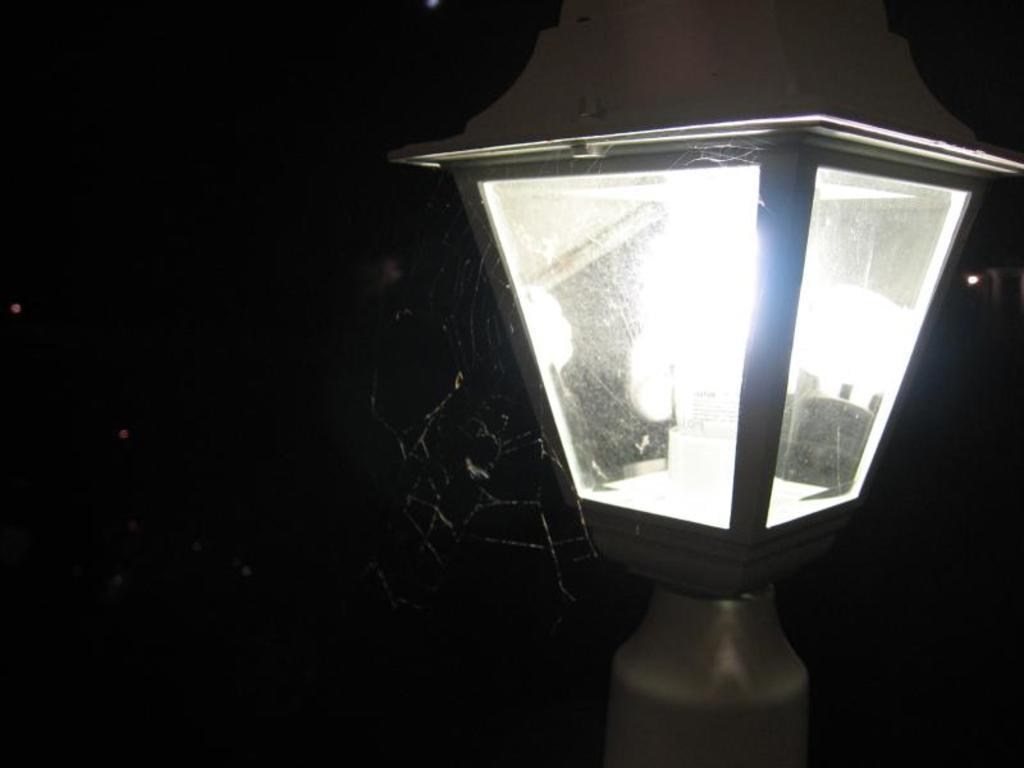Can you describe this image briefly? In this picture there is a lamp and the background is in black color. 